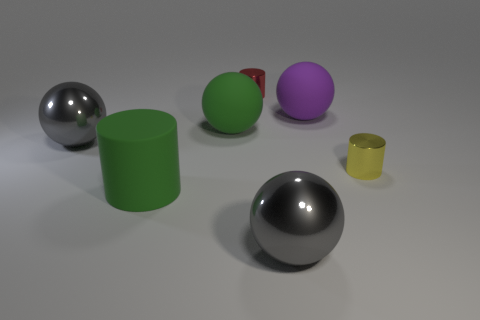What material is the large gray object behind the metal ball to the right of the large gray object that is left of the small red metal cylinder?
Your answer should be very brief. Metal. How many other things are the same shape as the red metal object?
Your answer should be very brief. 2. What is the color of the big matte ball that is in front of the big purple matte sphere?
Provide a short and direct response. Green. How many large gray metallic balls are right of the big sphere that is left of the green thing that is on the left side of the green rubber ball?
Ensure brevity in your answer.  1. What number of green rubber cylinders are in front of the gray thing to the right of the red shiny thing?
Ensure brevity in your answer.  0. There is a big green matte cylinder; what number of metallic objects are in front of it?
Ensure brevity in your answer.  1. How many other things are there of the same size as the yellow metallic cylinder?
Offer a terse response. 1. The red shiny thing that is the same shape as the yellow thing is what size?
Give a very brief answer. Small. What is the shape of the gray thing that is right of the red object?
Your response must be concise. Sphere. There is a tiny metal cylinder that is in front of the big rubber sphere that is left of the purple matte sphere; what color is it?
Keep it short and to the point. Yellow. 